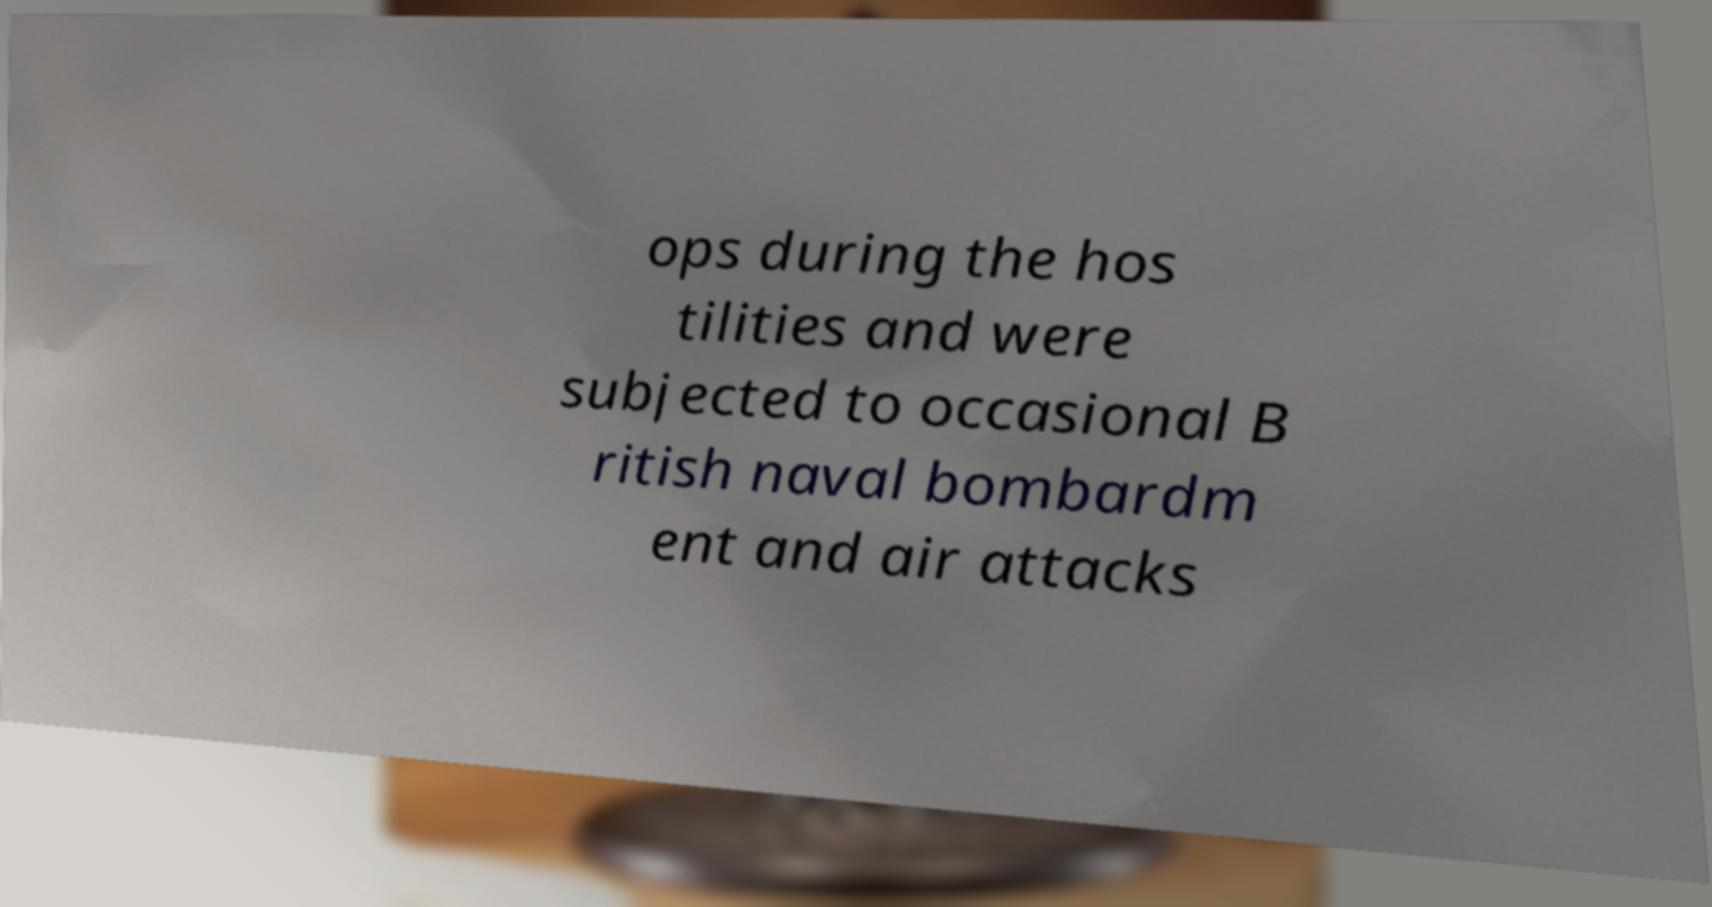There's text embedded in this image that I need extracted. Can you transcribe it verbatim? ops during the hos tilities and were subjected to occasional B ritish naval bombardm ent and air attacks 